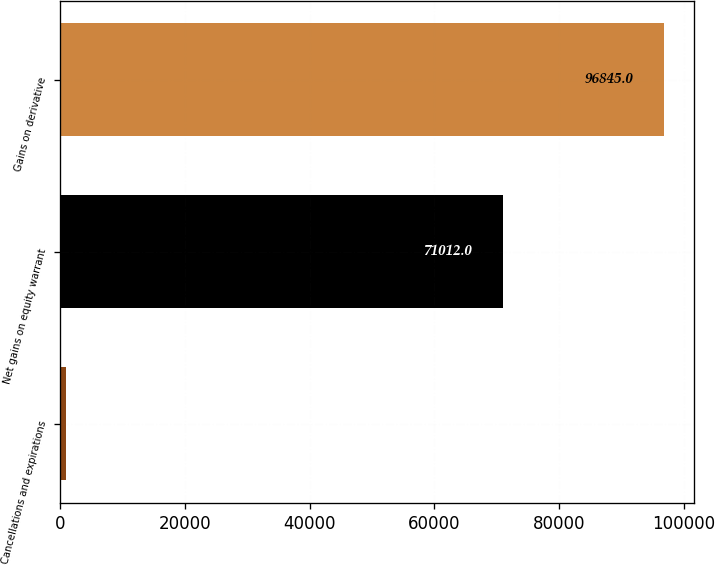Convert chart. <chart><loc_0><loc_0><loc_500><loc_500><bar_chart><fcel>Cancellations and expirations<fcel>Net gains on equity warrant<fcel>Gains on derivative<nl><fcel>856<fcel>71012<fcel>96845<nl></chart> 